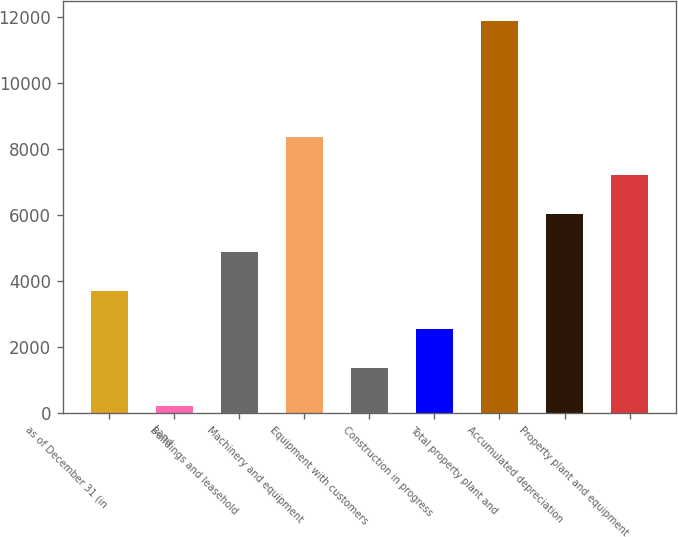Convert chart to OTSL. <chart><loc_0><loc_0><loc_500><loc_500><bar_chart><fcel>as of December 31 (in<fcel>Land<fcel>Buildings and leasehold<fcel>Machinery and equipment<fcel>Equipment with customers<fcel>Construction in progress<fcel>Total property plant and<fcel>Accumulated depreciation<fcel>Property plant and equipment<nl><fcel>3693.7<fcel>190<fcel>4861.6<fcel>8365.3<fcel>1357.9<fcel>2525.8<fcel>11869<fcel>6029.5<fcel>7197.4<nl></chart> 